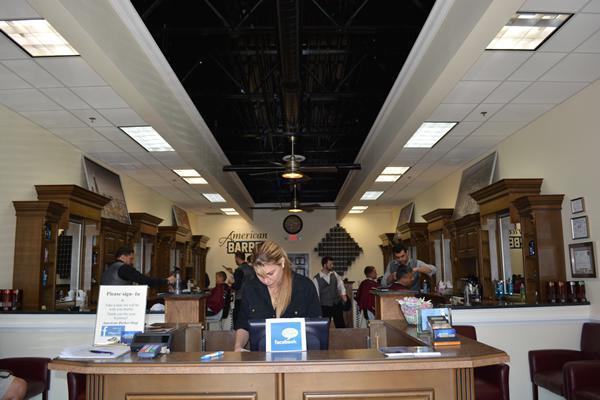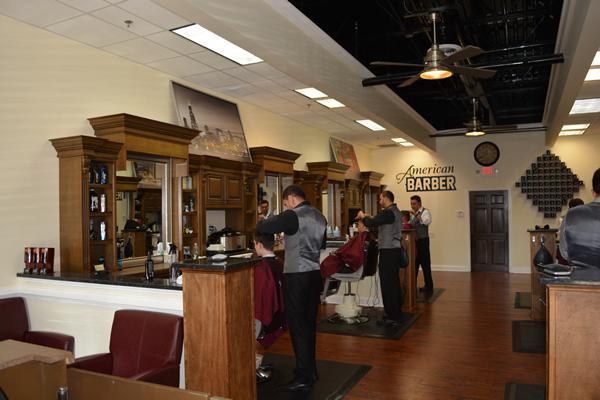The first image is the image on the left, the second image is the image on the right. Considering the images on both sides, is "Someone is at the desk in the left image." valid? Answer yes or no. Yes. The first image is the image on the left, the second image is the image on the right. Examine the images to the left and right. Is the description "There are at least three people in red capes getting there hair cut." accurate? Answer yes or no. Yes. 